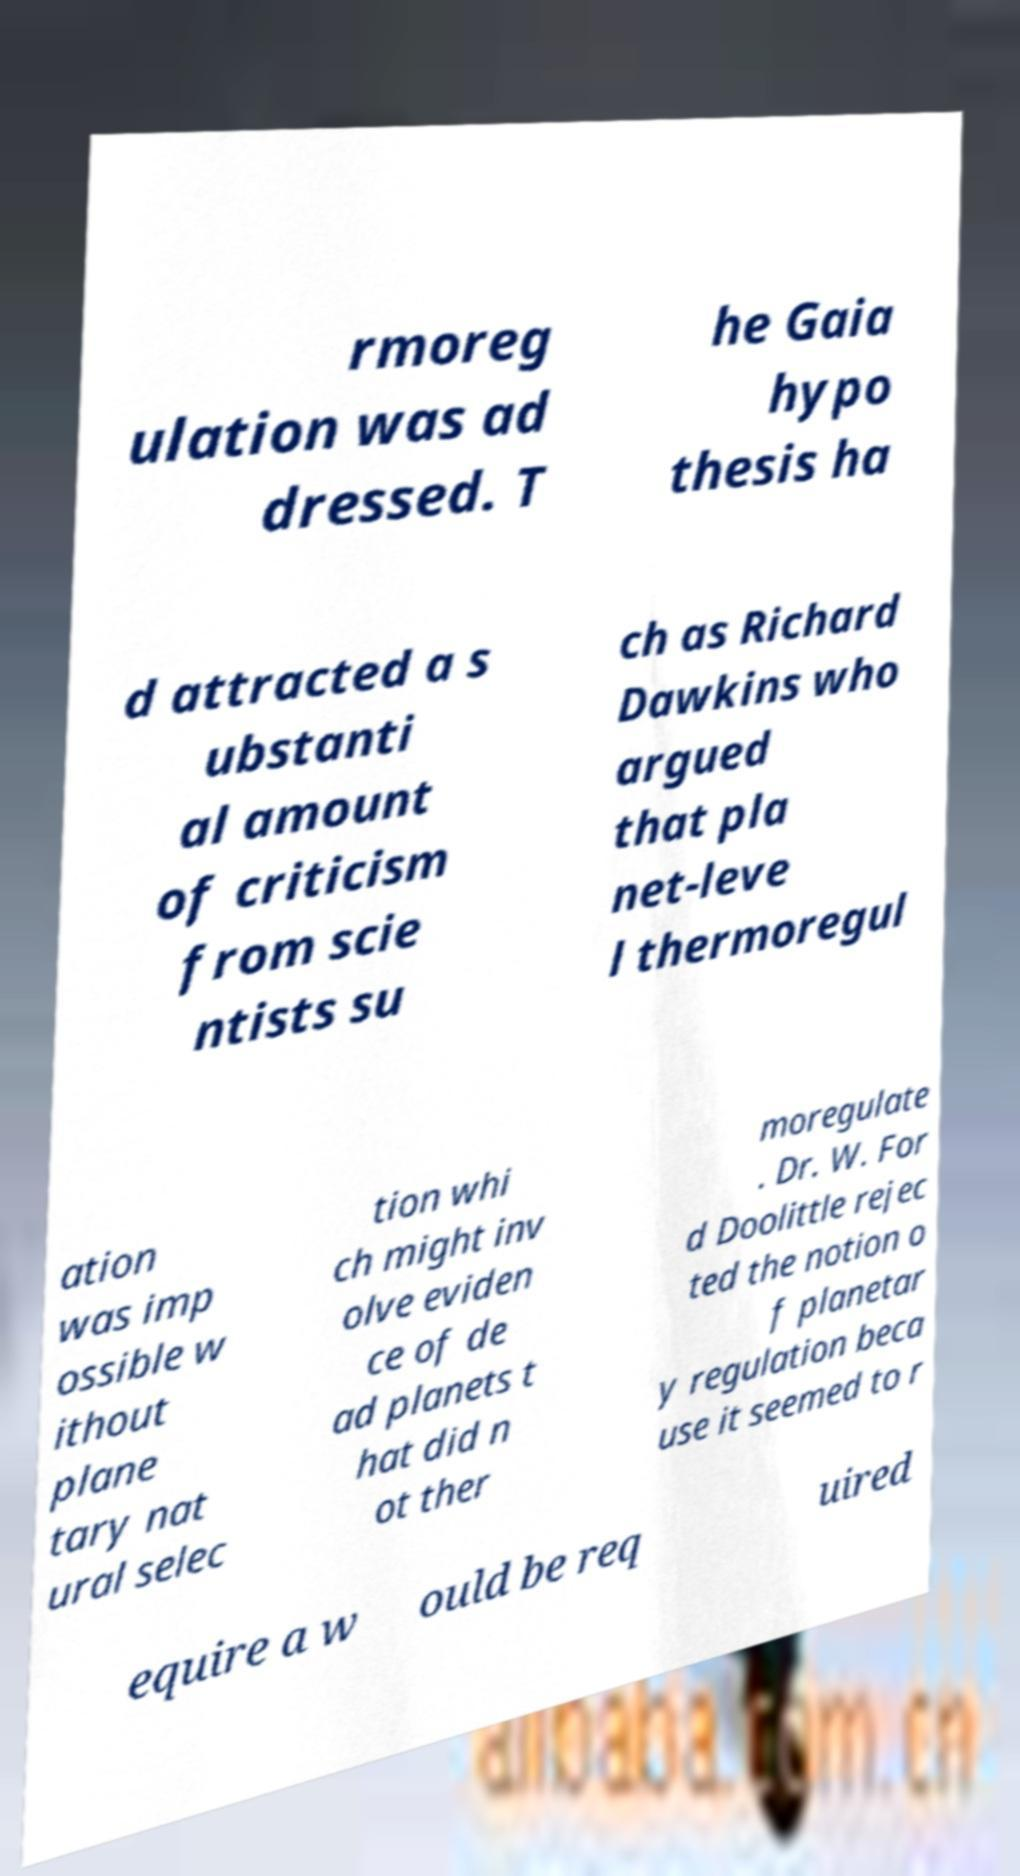There's text embedded in this image that I need extracted. Can you transcribe it verbatim? rmoreg ulation was ad dressed. T he Gaia hypo thesis ha d attracted a s ubstanti al amount of criticism from scie ntists su ch as Richard Dawkins who argued that pla net-leve l thermoregul ation was imp ossible w ithout plane tary nat ural selec tion whi ch might inv olve eviden ce of de ad planets t hat did n ot ther moregulate . Dr. W. For d Doolittle rejec ted the notion o f planetar y regulation beca use it seemed to r equire a w ould be req uired 